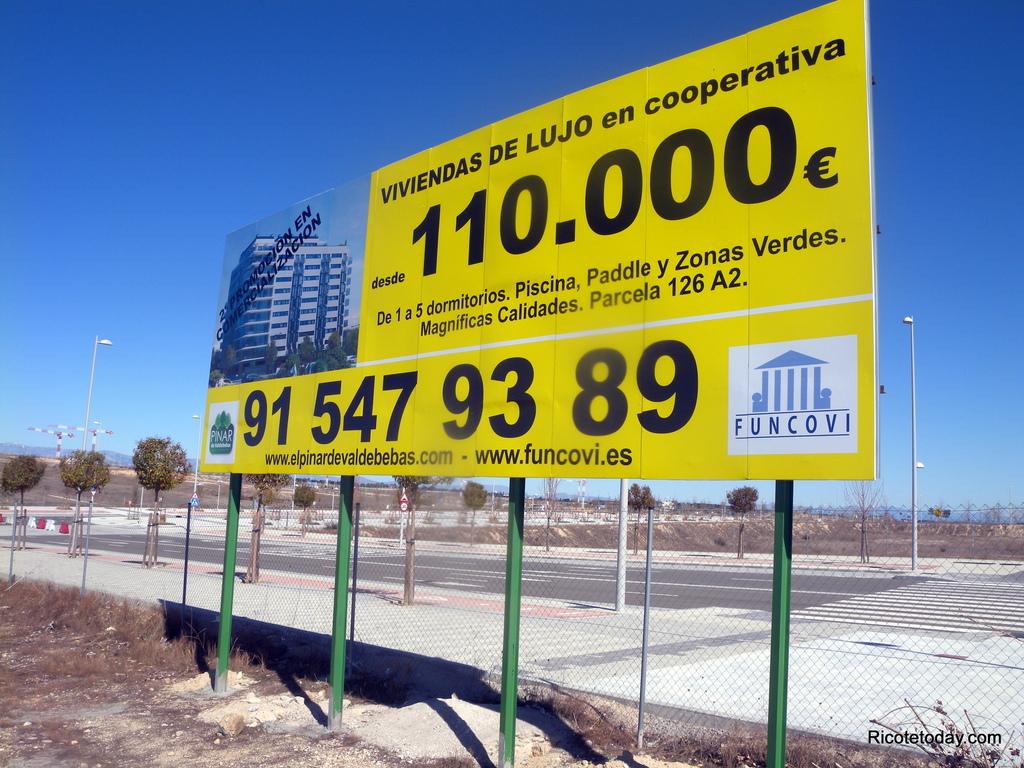How much is this land?
Provide a succinct answer. 110.000. What company put up this sign?
Offer a terse response. Funcovi. 